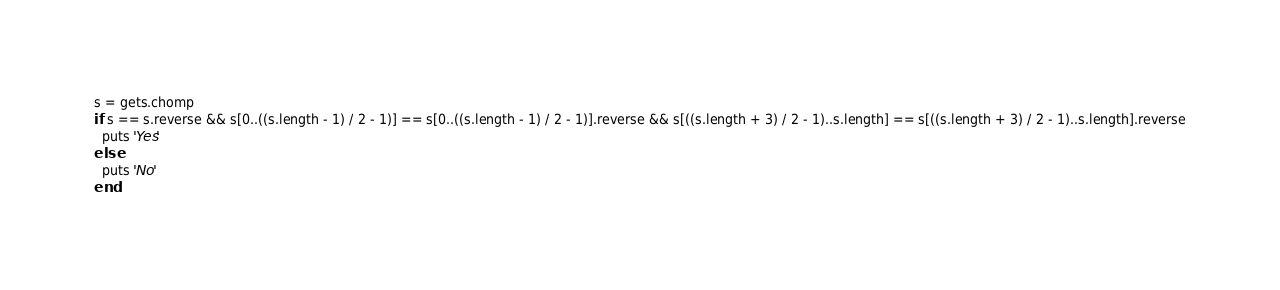<code> <loc_0><loc_0><loc_500><loc_500><_Ruby_>s = gets.chomp
if s == s.reverse && s[0..((s.length - 1) / 2 - 1)] == s[0..((s.length - 1) / 2 - 1)].reverse && s[((s.length + 3) / 2 - 1)..s.length] == s[((s.length + 3) / 2 - 1)..s.length].reverse
  puts 'Yes'
else
  puts 'No'
end</code> 